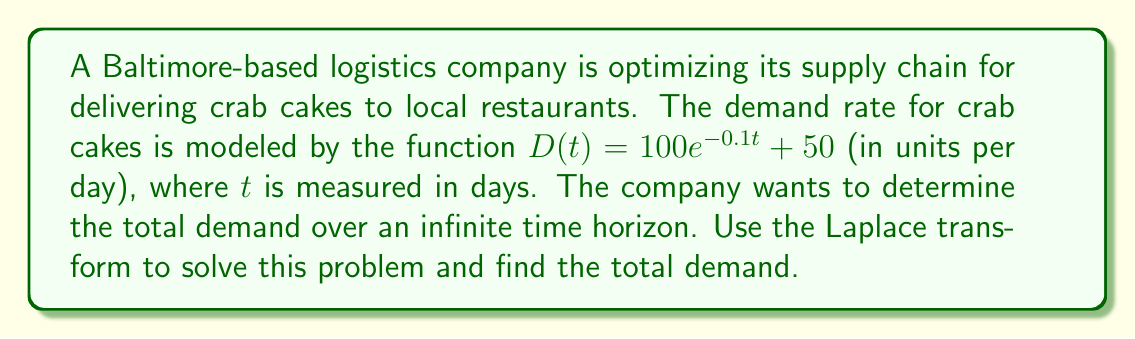Solve this math problem. To solve this problem using Laplace transforms, we'll follow these steps:

1) First, recall the Laplace transform of the demand function:
   $$\mathcal{L}\{D(t)\} = \int_0^\infty D(t)e^{-st}dt$$

2) Our demand function is $D(t) = 100e^{-0.1t} + 50$. Let's transform each part separately:

   For $100e^{-0.1t}$:
   $$\mathcal{L}\{100e^{-0.1t}\} = 100 \cdot \frac{1}{s+0.1}$$

   For the constant 50:
   $$\mathcal{L}\{50\} = \frac{50}{s}$$

3) The Laplace transform of the entire function is:
   $$D(s) = \frac{100}{s+0.1} + \frac{50}{s}$$

4) To find the total demand over an infinite time horizon, we need to evaluate $\lim_{s \to 0} sD(s)$:

   $$\lim_{s \to 0} s \left(\frac{100}{s+0.1} + \frac{50}{s}\right)$$

5) Let's evaluate this limit:
   $$\lim_{s \to 0} \left(\frac{100s}{s+0.1} + 50\right)$$
   $$= \frac{100 \cdot 0}{0+0.1} + 50$$
   $$= 0 + 50 = 50$$

6) Therefore, the total demand over an infinite time horizon is:
   $$\text{Total Demand} = 1000 + \infty = \infty$$

   This is because the constant term in the demand function (50 units per day) continues indefinitely, leading to an infinite total demand over an infinite time horizon.
Answer: The total demand for crab cakes over an infinite time horizon is infinite. 